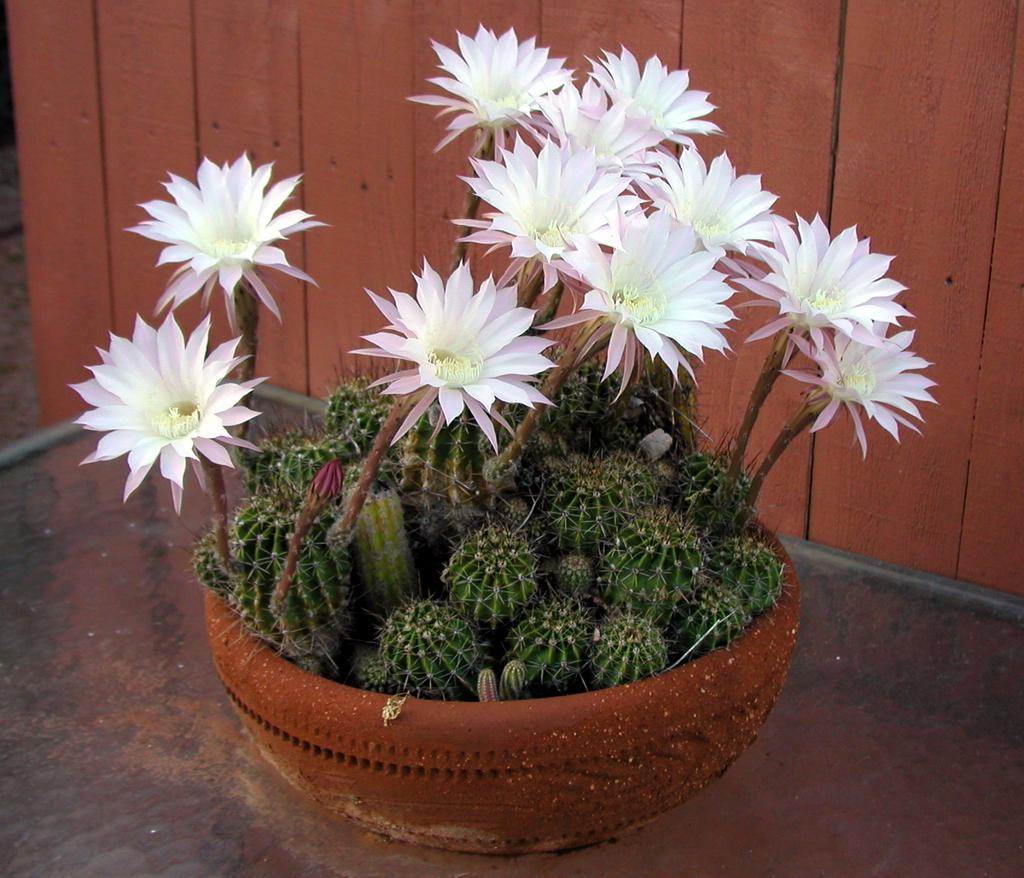What type of plant is in the image? There is a potted plant with flowers in the image. What can be seen in the background of the image? There is a wall in the background of the image. How many stalks of celery are visible in the image? There is no celery present in the image; it features a potted plant with flowers. 